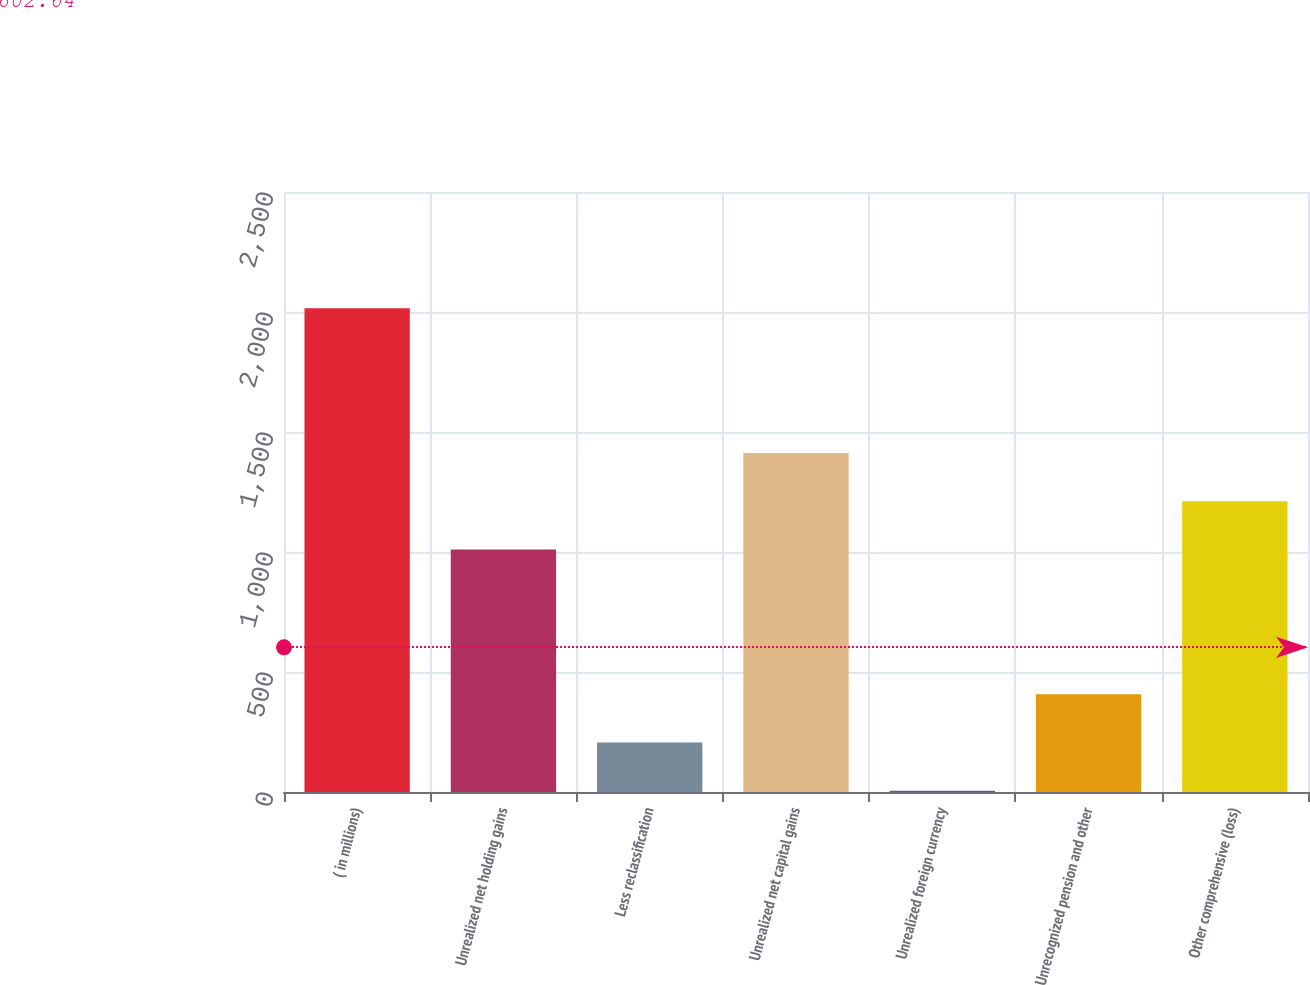Convert chart. <chart><loc_0><loc_0><loc_500><loc_500><bar_chart><fcel>( in millions)<fcel>Unrealized net holding gains<fcel>Less reclassification<fcel>Unrealized net capital gains<fcel>Unrealized foreign currency<fcel>Unrecognized pension and other<fcel>Other comprehensive (loss)<nl><fcel>2016<fcel>1010.5<fcel>206.1<fcel>1412.7<fcel>5<fcel>407.2<fcel>1211.6<nl></chart> 